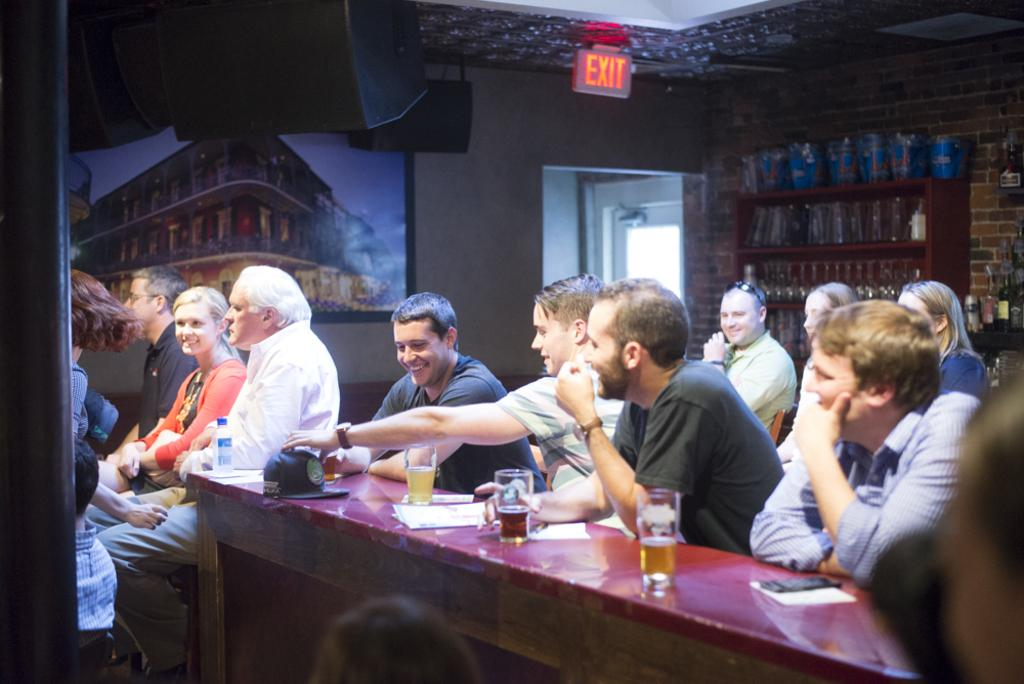What are the people in the image doing? The people in the image are sitting on chairs. What is present in the image besides the people? There is a table in the image. What can be seen on the table? There are wine glasses, papers, and a mobile phone on the table. What type of underwear is visible on the table in the image? There is no underwear present in the image; the objects on the table include wine glasses, papers, and a mobile phone. How many units of forks are visible in the image? There are no forks visible in the image; the utensils mentioned are wine glasses. 